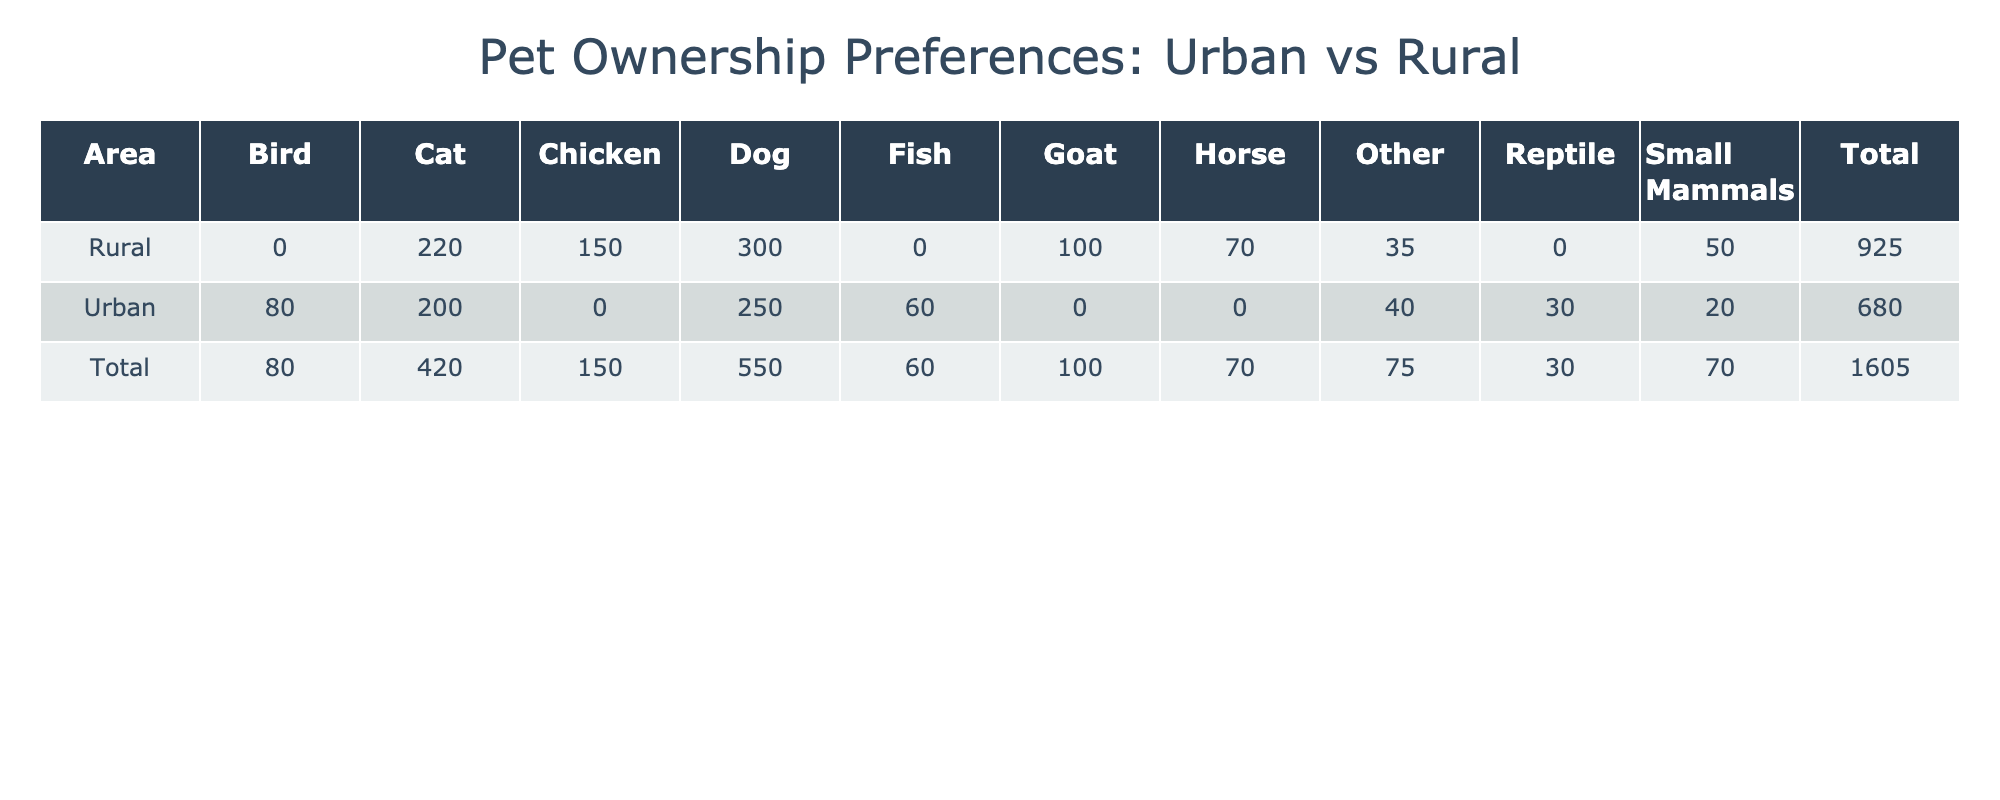What is the total number of pets owned in urban areas? To find the total number of pets owned in urban areas, we add the frequencies of each pet type under the Urban category: 250 (Dog) + 200 (Cat) + 80 (Bird) + 60 (Fish) + 30 (Reptile) + 20 (Small Mammals) + 40 (Other) = 680.
Answer: 680 Which pet type has the highest frequency in rural areas? Looking at the Rural category, the highest frequency can be determined by comparing the values: 300 (Dog), 220 (Cat), 150 (Chicken), 100 (Goat), 70 (Horse), 50 (Small Mammals), and 35 (Other). The maximum value is 300 (Dog).
Answer: Dog How many more dogs are owned in rural areas compared to urban areas? The number of dogs in rural areas is 300, and in urban areas, it is 250. To find the difference, we calculate: 300 - 250 = 50.
Answer: 50 Is the frequency of owning chickens higher in urban or rural areas? The frequency of chickens is only present in rural areas with a value of 150, while there are no chickens listed under urban areas, which means the frequency in urban areas is 0. Therefore, 150 > 0.
Answer: Yes What is the total frequency of pets classified as 'Other' in both urban and rural areas? The frequency of 'Other' in urban areas is 40, and in rural areas, it is 35. To find the total for 'Other', we add these two: 40 + 35 = 75.
Answer: 75 What percentage of urban pet ownership is accounted for by small mammals? The frequency of small mammals in urban areas is 20. The total number of pets in urban areas is 680 (as previously calculated). To find the percentage: (20 / 680) * 100 = 2.94%.
Answer: 2.94% In rural areas, what is the average number of pets per type, considering the data provided? In rural areas, there are 6 types of pets (Dog, Cat, Chicken, Goat, Horse, Small Mammals, Other) with frequencies of 300, 220, 150, 100, 70, 50, and 35 respectively. First, we sum these values: 300 + 220 + 150 + 100 + 70 + 50 + 35 = 1025. To find the average, we divide by 7 (the number of types): 1025 / 7 = 146.43.
Answer: 146.43 Which area has a higher total frequency of cats and fish combined? In urban areas, cats have a frequency of 200 and fish have 60. In rural areas, cats have 220 but fish are not listed so their frequency is 0. For urban: 200 + 60 = 260. For rural: 220 + 0 = 220. Since 260 > 220, urban has a higher total.
Answer: Urban How many pet types are present in urban areas? The pet types listed under urban areas are Dog, Cat, Bird, Fish, Reptile, Small Mammals, and Other. This totals to 7 distinct types of pets.
Answer: 7 